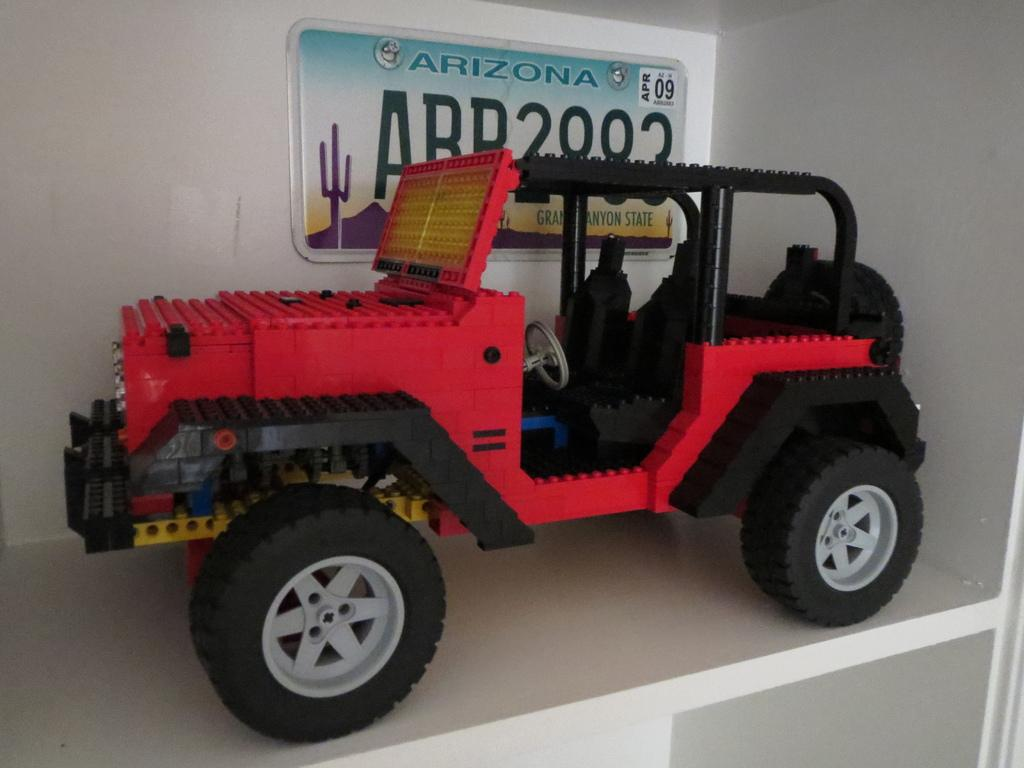What is the focus of the image? The image is zoomed in on a red color toy jeep. Where is the toy jeep located in the image? The toy jeep appears to be placed on a shelf. What can be seen in the background of the image? There is a text on the wall in the background of the image. How many chickens are sitting on the toy jeep in the image? There are no chickens present in the image; it features a red color toy jeep on a shelf. What type of insect can be seen crawling on the text in the background? There are no insects visible in the image; it only shows a toy jeep on a shelf and text on the wall in the background. 